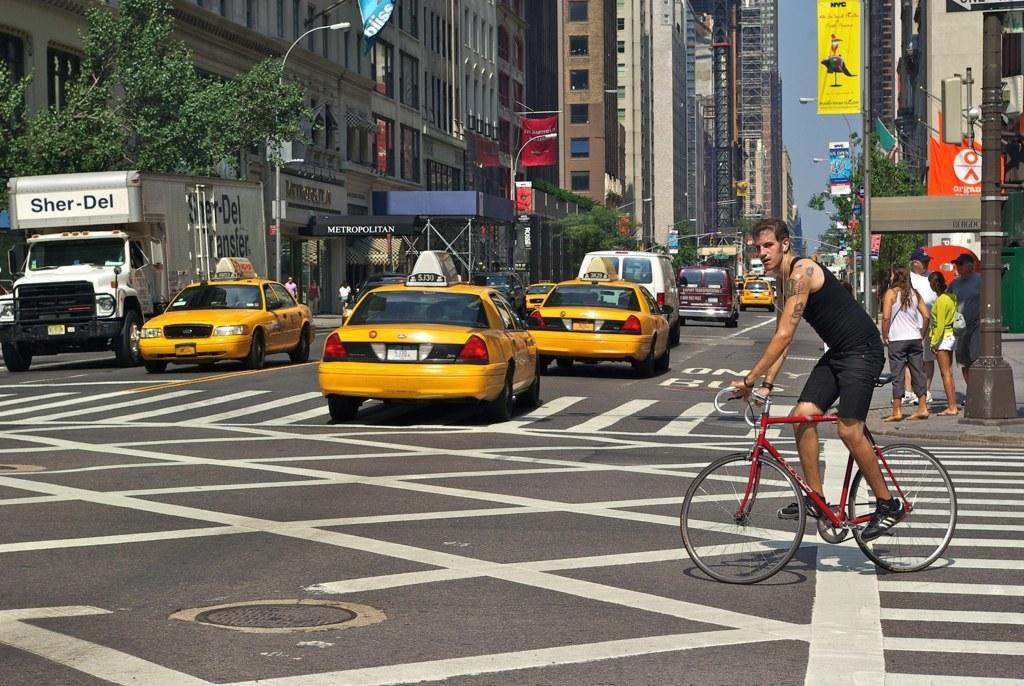What company owns the big truck on the left?
Your answer should be compact. Sher-del. What is on the orange sign?
Provide a succinct answer. Organ. 